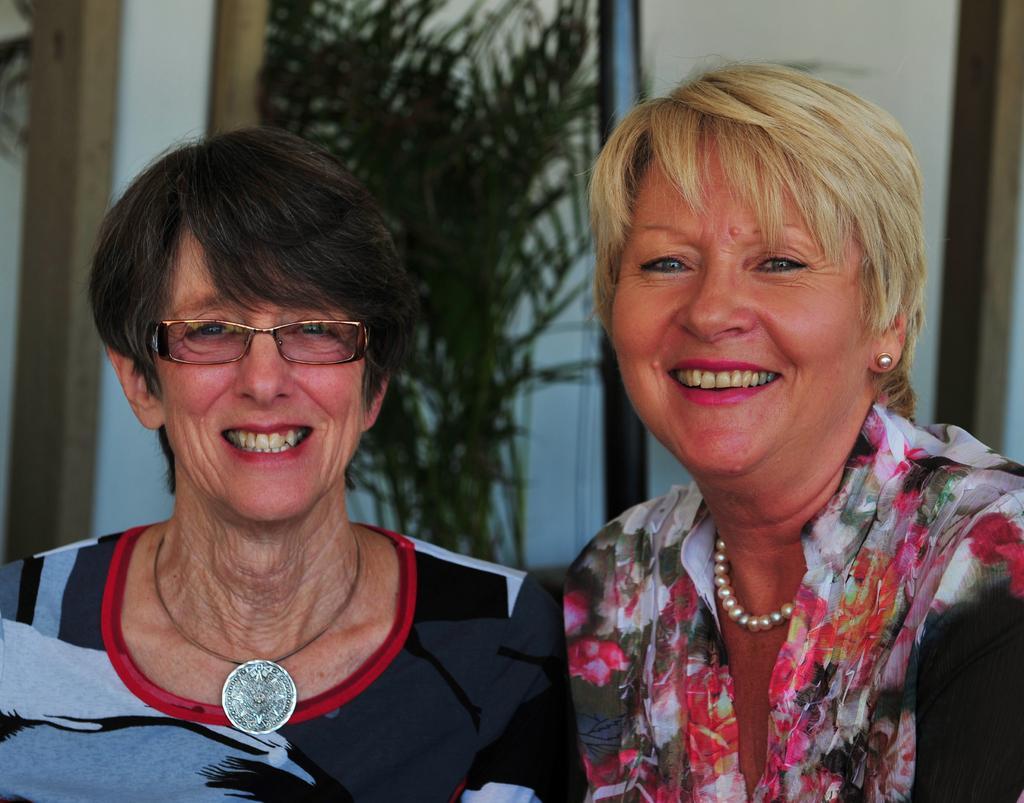In one or two sentences, can you explain what this image depicts? In the image there are two women, both of them are smiling and one of the women is wearing spectacles, behind the women there is a plant and beside the plant there is a wall. 